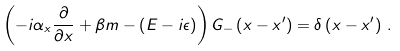<formula> <loc_0><loc_0><loc_500><loc_500>\left ( - i \alpha _ { x } \frac { \partial } { \partial x } + \beta m - \left ( E - i \epsilon \right ) \right ) G _ { - } \left ( x - x ^ { \prime } \right ) = \delta \left ( x - x ^ { \prime } \right ) \, .</formula> 